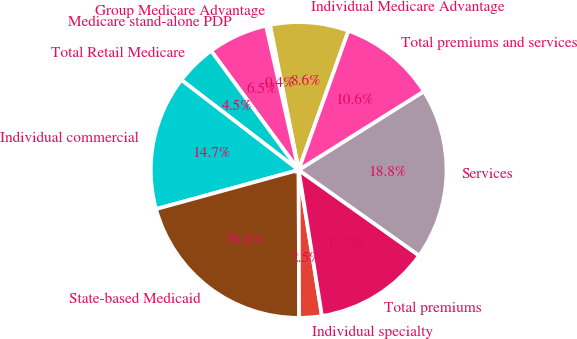Convert chart to OTSL. <chart><loc_0><loc_0><loc_500><loc_500><pie_chart><fcel>Individual Medicare Advantage<fcel>Group Medicare Advantage<fcel>Medicare stand-alone PDP<fcel>Total Retail Medicare<fcel>Individual commercial<fcel>State-based Medicaid<fcel>Individual specialty<fcel>Total premiums<fcel>Services<fcel>Total premiums and services<nl><fcel>8.58%<fcel>0.43%<fcel>6.54%<fcel>4.5%<fcel>14.68%<fcel>20.79%<fcel>2.47%<fcel>12.65%<fcel>18.75%<fcel>10.61%<nl></chart> 